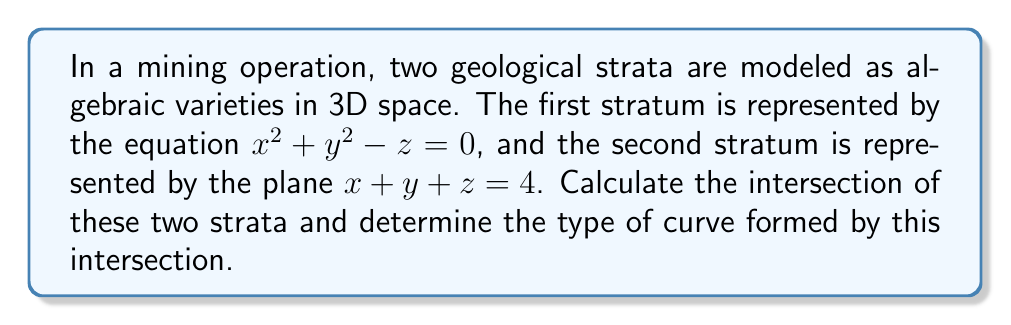Teach me how to tackle this problem. To find the intersection of the two geological strata, we need to solve the system of equations:

$$\begin{cases}
x^2 + y^2 - z = 0 \\
x + y + z = 4
\end{cases}$$

Step 1: Substitute $z$ from the second equation into the first equation:
$x^2 + y^2 - (4 - x - y) = 0$

Step 2: Simplify the equation:
$x^2 + y^2 - 4 + x + y = 0$
$x^2 + x + y^2 + y - 4 = 0$

Step 3: Complete the square for both $x$ and $y$ terms:
$(x^2 + x) + (y^2 + y) - 4 = 0$
$(x^2 + x + \frac{1}{4}) + (y^2 + y + \frac{1}{4}) - 4 - \frac{1}{4} - \frac{1}{4} = 0$
$(x + \frac{1}{2})^2 + (y + \frac{1}{2})^2 = \frac{9}{2}$

Step 4: Make a change of variables:
Let $X = x + \frac{1}{2}$ and $Y = y + \frac{1}{2}$

The equation becomes:
$X^2 + Y^2 = \frac{9}{2}$

Step 5: Recognize the equation:
This is the equation of a circle in the XY-plane with center $(0, 0)$ and radius $\sqrt{\frac{9}{2}} = \frac{3}{\sqrt{2}}$.

Step 6: Transform back to the original coordinates:
The circle is centered at $(-\frac{1}{2}, -\frac{1}{2})$ in the xy-plane.

Step 7: Find the z-coordinate:
Using the plane equation: $x + y + z = 4$
At the center: $-\frac{1}{2} + (-\frac{1}{2}) + z = 4$
$z = 5$

Therefore, the intersection is a circle in 3D space with:
- Center: $(-\frac{1}{2}, -\frac{1}{2}, 5)$
- Radius: $\frac{3}{\sqrt{2}}$
- Lying on the plane $x + y + z = 4$
Answer: A circle with center $(-\frac{1}{2}, -\frac{1}{2}, 5)$ and radius $\frac{3}{\sqrt{2}}$ 